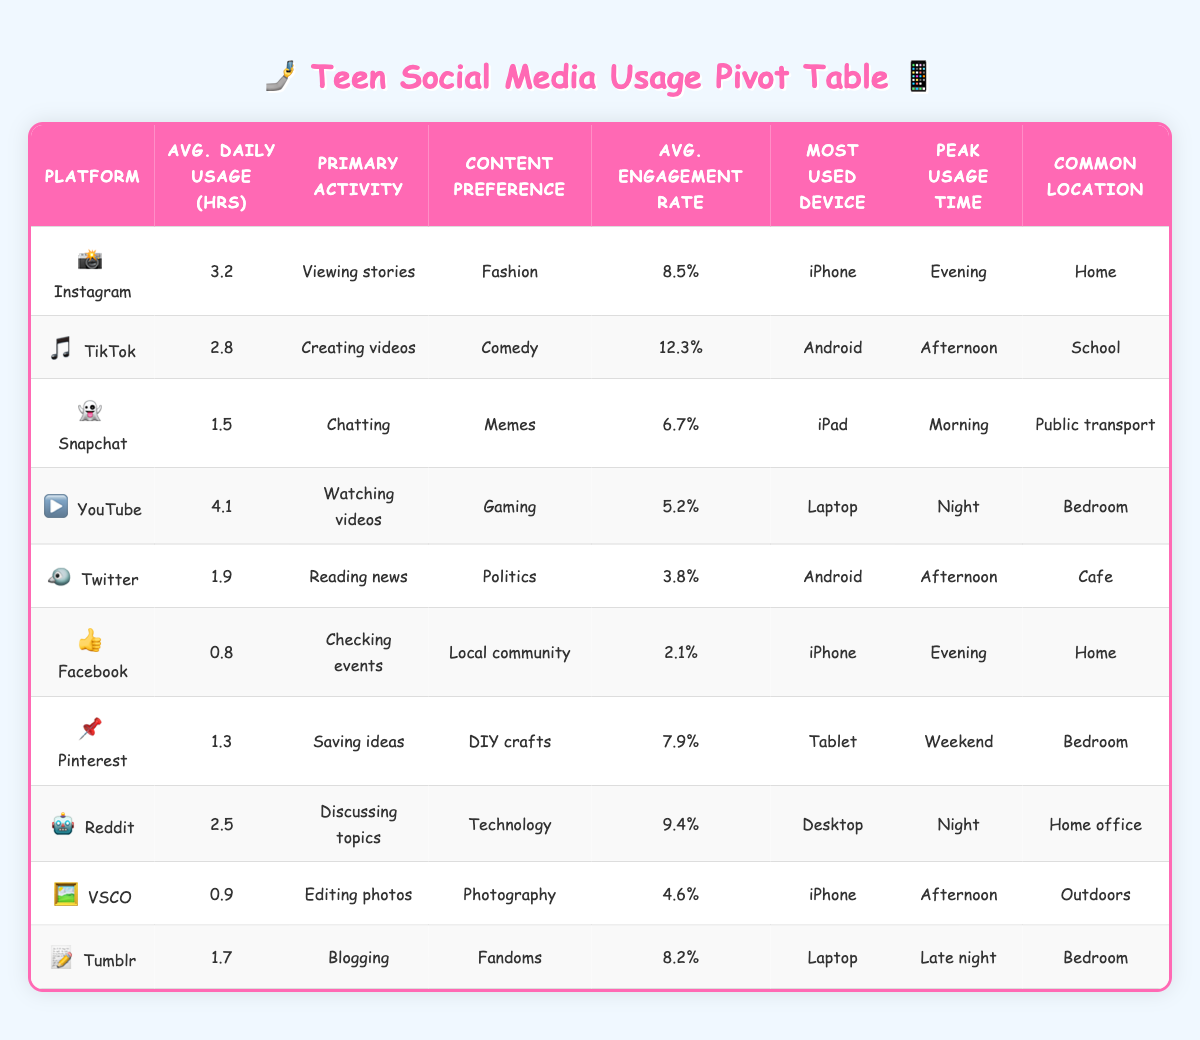What is the average daily usage time on Instagram? From the table, the daily usage hours for Instagram is listed as 3.2. Thus, the average daily usage time on Instagram is simply this value.
Answer: 3.2 Which platform has the highest engagement rate? By looking at the engagement rates listed for each platform, TikTok has an engagement rate of 12.3%, which is the highest compared to the other platforms.
Answer: TikTok What is the total daily usage time for all platforms? We need to sum up the daily usage hours: 3.2 + 2.8 + 1.5 + 4.1 + 1.9 + 0.8 + 1.3 + 2.5 + 0.9 + 1.7 = 20.7. Therefore, the total daily usage time for all platforms is 20.7 hours.
Answer: 20.7 Is the primary activity on Pinterest saving ideas? Looking at the primary activity listed for Pinterest, it states "Saving ideas," which confirms the statement is true.
Answer: Yes Which platform has the least daily usage hours, and what is that time? The least daily usage hours are for Facebook at 0.8 hours, as no other platform has a lower value listed.
Answer: Facebook, 0.8 What is the average engagement rate across all platforms? To find the average engagement rate, sum the engagement rates (8.5 + 12.3 + 6.7 + 5.2 + 3.8 + 2.1 + 7.9 + 9.4 + 4.6 + 8.2) = 68.7, and then divide by the number of platforms (10). Therefore, the average engagement rate is 68.7 / 10 = 6.87.
Answer: 6.87 What device is predominantly used for Snapchat? The device listed for Snapchat usage is an iPad, indicating the predominant device for this platform is indeed an iPad.
Answer: iPad During which time of day is YouTube most commonly used? As listed in the table, the peak usage time for YouTube is "Night." Thus, YouTube is most commonly used during the night.
Answer: Night Are there any platforms where users primarily engage in chatting? Looking through the primary activities listed, Snapchat is the only platform where the primary activity recorded is chatting. This confirms the presence of such a platform.
Answer: Yes What content preference is associated with TikTok? The content preference listed for TikTok is "Comedy," which directly answers the question regarding this platform's content focus.
Answer: Comedy 